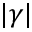Convert formula to latex. <formula><loc_0><loc_0><loc_500><loc_500>| \gamma |</formula> 